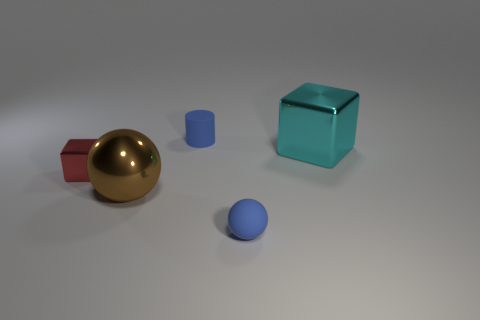Add 5 metallic things. How many objects exist? 10 Subtract all blocks. How many objects are left? 3 Subtract 0 cyan spheres. How many objects are left? 5 Subtract all small cylinders. Subtract all small brown matte cubes. How many objects are left? 4 Add 4 large brown metallic balls. How many large brown metallic balls are left? 5 Add 3 large purple balls. How many large purple balls exist? 3 